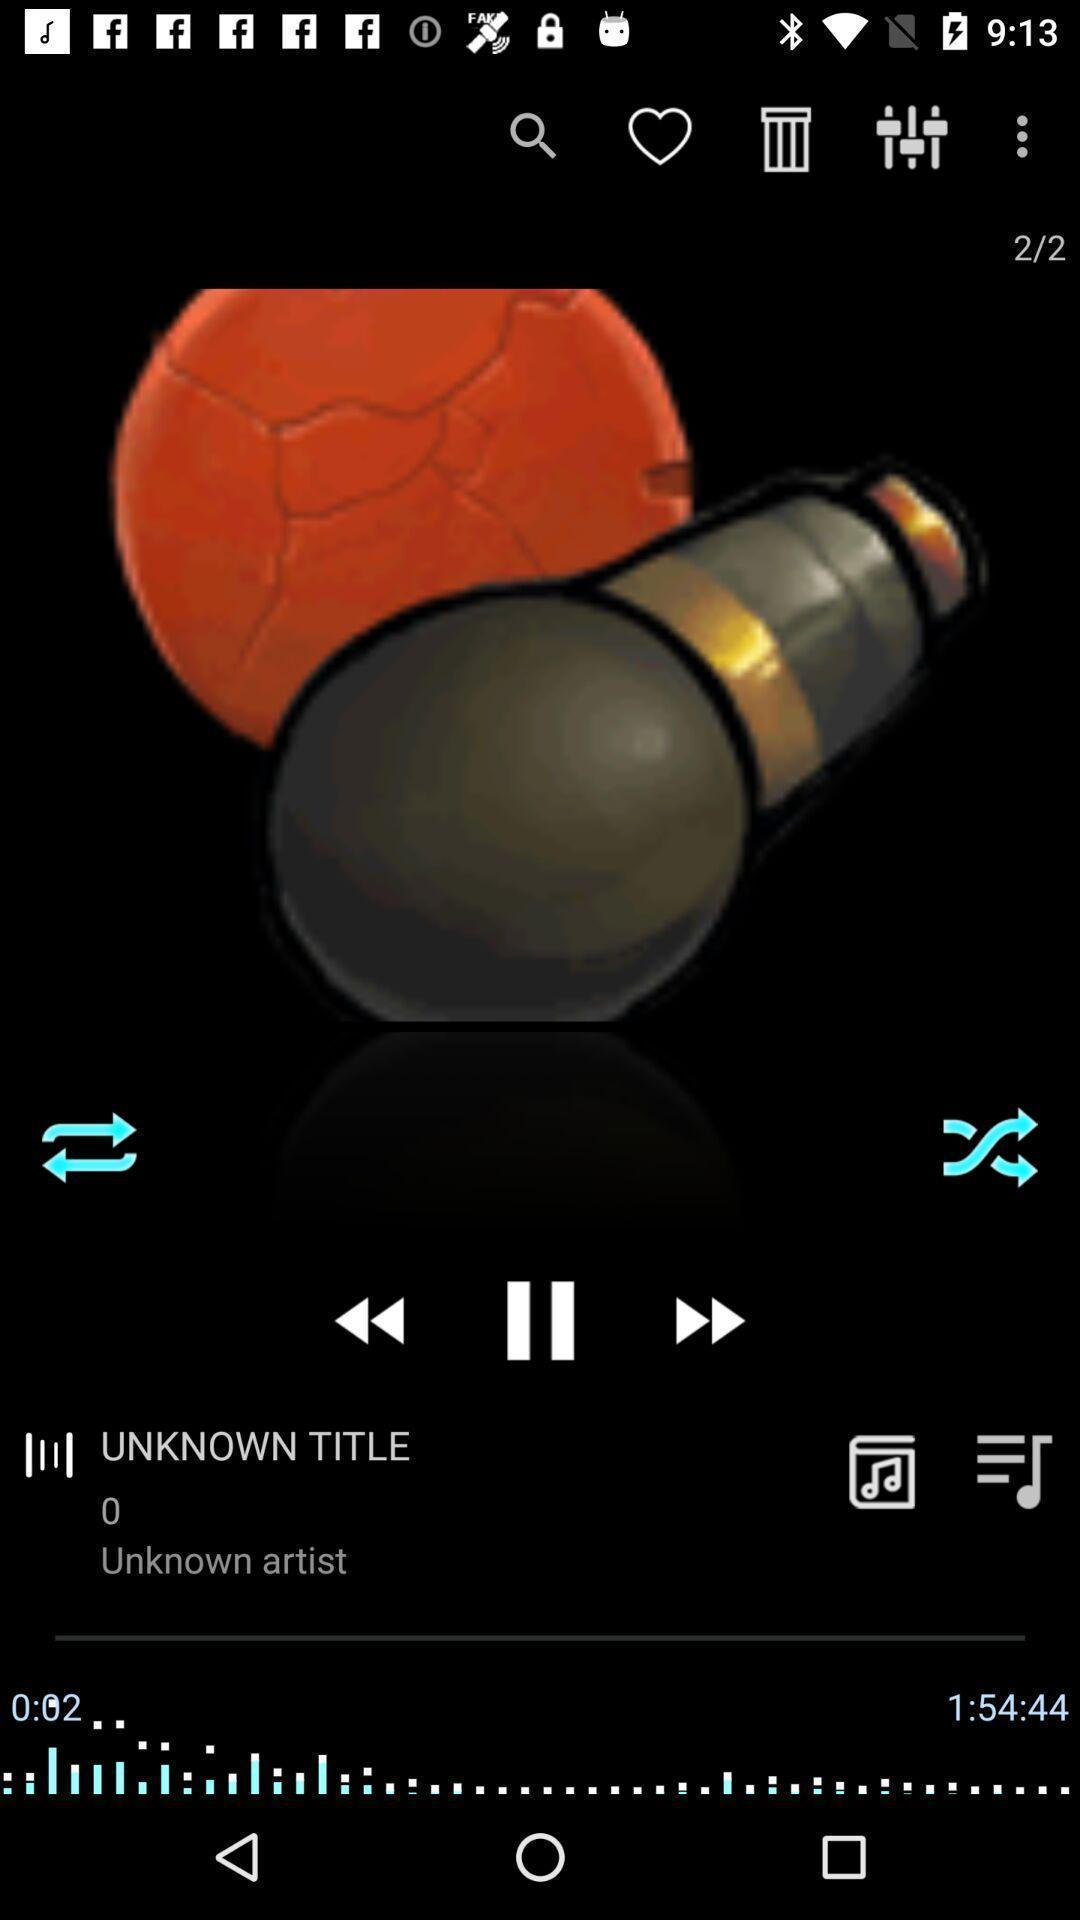Give me a narrative description of this picture. Track playing n a music app. 